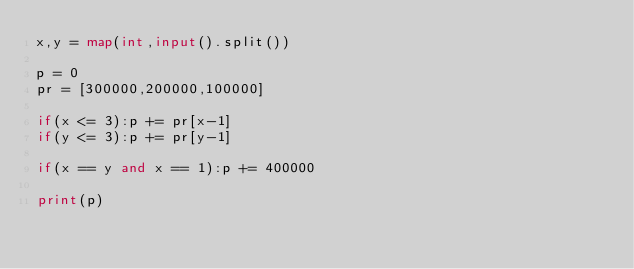Convert code to text. <code><loc_0><loc_0><loc_500><loc_500><_Python_>x,y = map(int,input().split())

p = 0
pr = [300000,200000,100000]

if(x <= 3):p += pr[x-1]
if(y <= 3):p += pr[y-1]

if(x == y and x == 1):p += 400000

print(p)</code> 